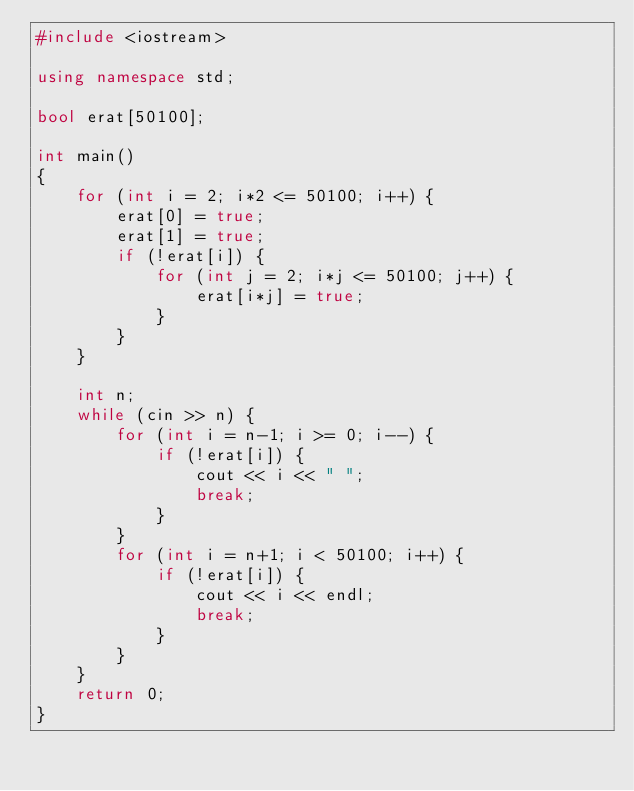Convert code to text. <code><loc_0><loc_0><loc_500><loc_500><_C++_>#include <iostream>

using namespace std;

bool erat[50100];

int main()
{
    for (int i = 2; i*2 <= 50100; i++) {
        erat[0] = true;
        erat[1] = true;
        if (!erat[i]) {
            for (int j = 2; i*j <= 50100; j++) {
                erat[i*j] = true;
            }
        }
    }

    int n;
    while (cin >> n) {
        for (int i = n-1; i >= 0; i--) {
            if (!erat[i]) {
                cout << i << " ";
                break;
            }
        }
        for (int i = n+1; i < 50100; i++) {
            if (!erat[i]) {
                cout << i << endl;
                break;
            }
        }
    }
    return 0;
}</code> 